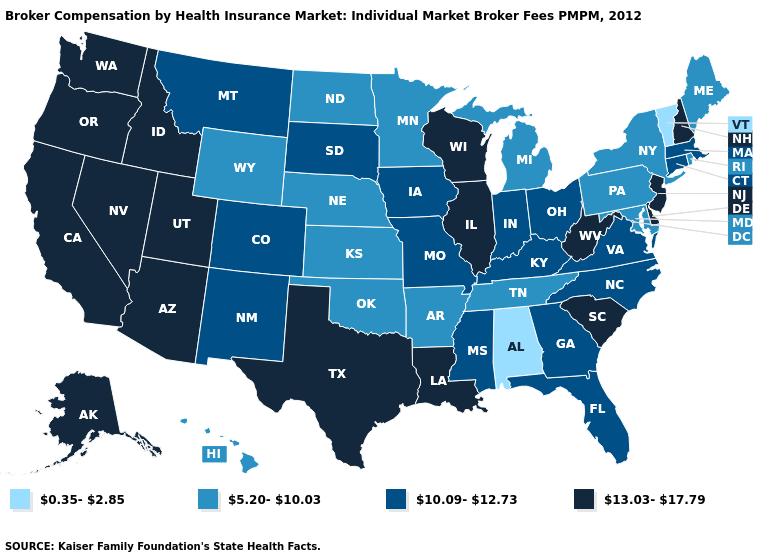Which states have the highest value in the USA?
Keep it brief. Alaska, Arizona, California, Delaware, Idaho, Illinois, Louisiana, Nevada, New Hampshire, New Jersey, Oregon, South Carolina, Texas, Utah, Washington, West Virginia, Wisconsin. Among the states that border New York , which have the highest value?
Keep it brief. New Jersey. Among the states that border New Jersey , does New York have the highest value?
Keep it brief. No. What is the value of Kansas?
Answer briefly. 5.20-10.03. Name the states that have a value in the range 13.03-17.79?
Write a very short answer. Alaska, Arizona, California, Delaware, Idaho, Illinois, Louisiana, Nevada, New Hampshire, New Jersey, Oregon, South Carolina, Texas, Utah, Washington, West Virginia, Wisconsin. Does the first symbol in the legend represent the smallest category?
Write a very short answer. Yes. What is the value of Montana?
Give a very brief answer. 10.09-12.73. What is the value of Oklahoma?
Answer briefly. 5.20-10.03. Does the first symbol in the legend represent the smallest category?
Write a very short answer. Yes. What is the highest value in states that border North Carolina?
Answer briefly. 13.03-17.79. What is the lowest value in states that border Massachusetts?
Give a very brief answer. 0.35-2.85. Which states have the lowest value in the USA?
Concise answer only. Alabama, Vermont. What is the highest value in the MidWest ?
Write a very short answer. 13.03-17.79. Name the states that have a value in the range 0.35-2.85?
Keep it brief. Alabama, Vermont. 